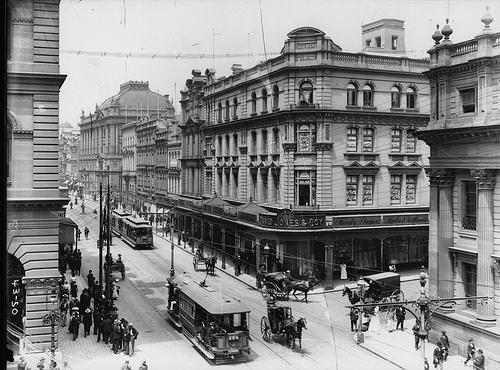How many people are there?
Give a very brief answer. 1. 